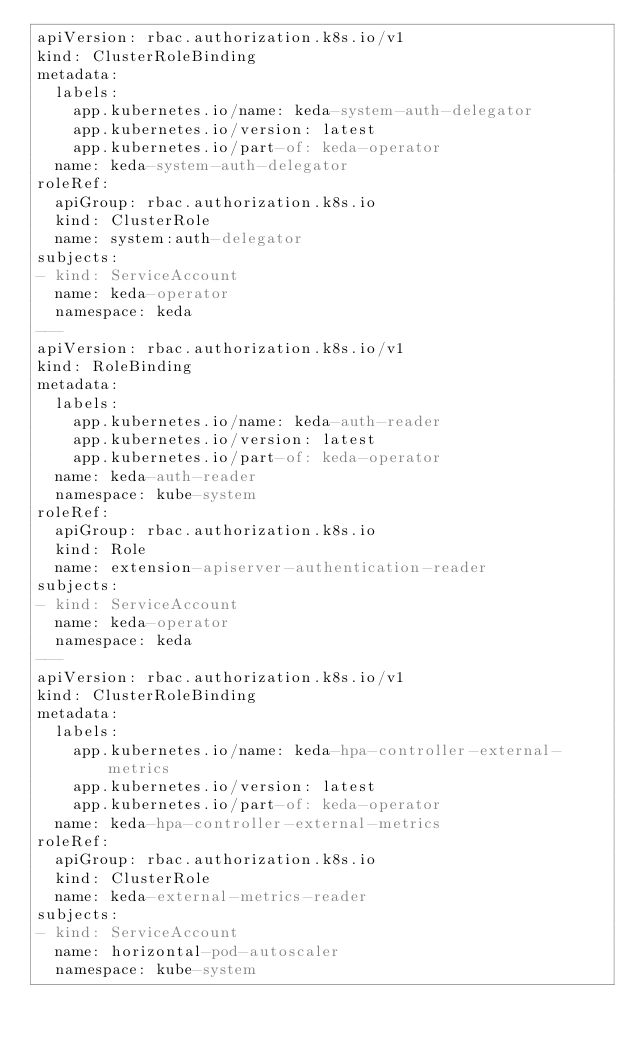Convert code to text. <code><loc_0><loc_0><loc_500><loc_500><_YAML_>apiVersion: rbac.authorization.k8s.io/v1
kind: ClusterRoleBinding
metadata:
  labels:
    app.kubernetes.io/name: keda-system-auth-delegator
    app.kubernetes.io/version: latest
    app.kubernetes.io/part-of: keda-operator
  name: keda-system-auth-delegator
roleRef:
  apiGroup: rbac.authorization.k8s.io
  kind: ClusterRole
  name: system:auth-delegator
subjects:
- kind: ServiceAccount
  name: keda-operator
  namespace: keda
---
apiVersion: rbac.authorization.k8s.io/v1
kind: RoleBinding
metadata:
  labels:
    app.kubernetes.io/name: keda-auth-reader
    app.kubernetes.io/version: latest
    app.kubernetes.io/part-of: keda-operator
  name: keda-auth-reader
  namespace: kube-system
roleRef:
  apiGroup: rbac.authorization.k8s.io
  kind: Role
  name: extension-apiserver-authentication-reader
subjects:
- kind: ServiceAccount
  name: keda-operator
  namespace: keda
---
apiVersion: rbac.authorization.k8s.io/v1
kind: ClusterRoleBinding
metadata:
  labels:
    app.kubernetes.io/name: keda-hpa-controller-external-metrics
    app.kubernetes.io/version: latest
    app.kubernetes.io/part-of: keda-operator
  name: keda-hpa-controller-external-metrics
roleRef:
  apiGroup: rbac.authorization.k8s.io
  kind: ClusterRole
  name: keda-external-metrics-reader
subjects:
- kind: ServiceAccount
  name: horizontal-pod-autoscaler
  namespace: kube-system
</code> 